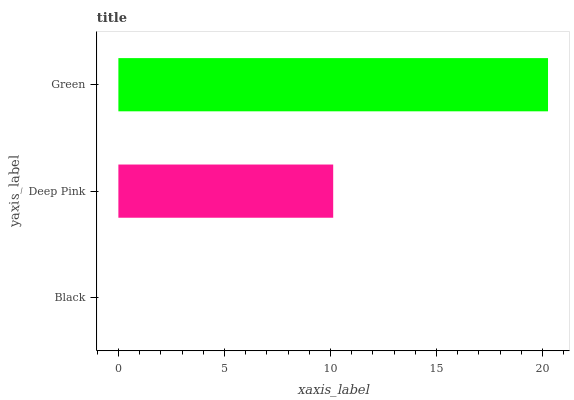Is Black the minimum?
Answer yes or no. Yes. Is Green the maximum?
Answer yes or no. Yes. Is Deep Pink the minimum?
Answer yes or no. No. Is Deep Pink the maximum?
Answer yes or no. No. Is Deep Pink greater than Black?
Answer yes or no. Yes. Is Black less than Deep Pink?
Answer yes or no. Yes. Is Black greater than Deep Pink?
Answer yes or no. No. Is Deep Pink less than Black?
Answer yes or no. No. Is Deep Pink the high median?
Answer yes or no. Yes. Is Deep Pink the low median?
Answer yes or no. Yes. Is Green the high median?
Answer yes or no. No. Is Black the low median?
Answer yes or no. No. 